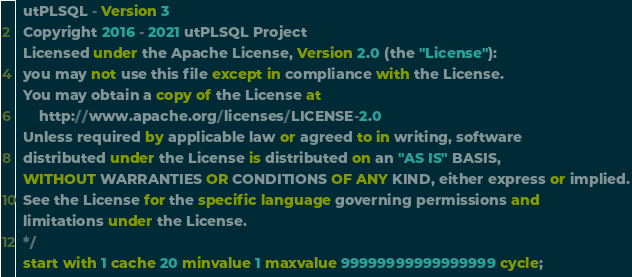<code> <loc_0><loc_0><loc_500><loc_500><_SQL_>  utPLSQL - Version 3
  Copyright 2016 - 2021 utPLSQL Project
  Licensed under the Apache License, Version 2.0 (the "License"):
  you may not use this file except in compliance with the License.
  You may obtain a copy of the License at
      http://www.apache.org/licenses/LICENSE-2.0
  Unless required by applicable law or agreed to in writing, software
  distributed under the License is distributed on an "AS IS" BASIS,
  WITHOUT WARRANTIES OR CONDITIONS OF ANY KIND, either express or implied.
  See the License for the specific language governing permissions and
  limitations under the License.
  */
  start with 1 cache 20 minvalue 1 maxvalue 99999999999999999 cycle;</code> 